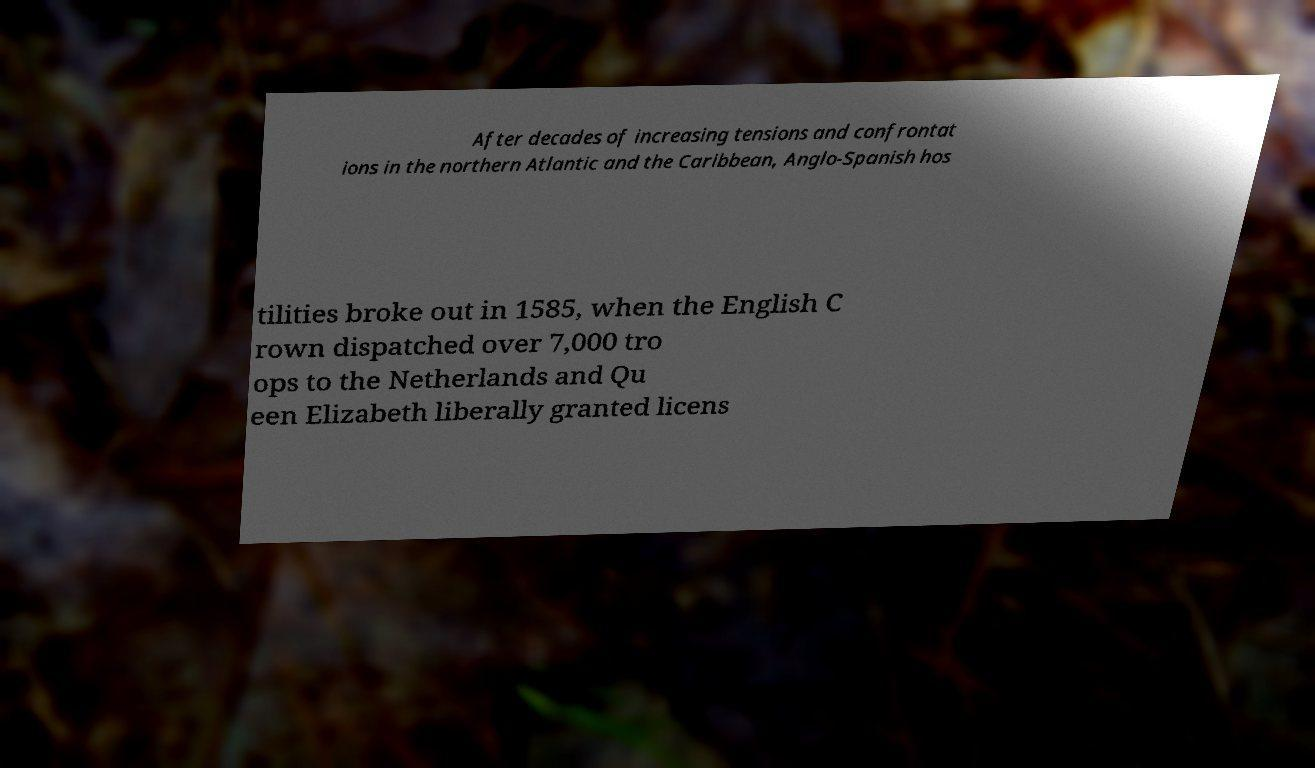What messages or text are displayed in this image? I need them in a readable, typed format. After decades of increasing tensions and confrontat ions in the northern Atlantic and the Caribbean, Anglo-Spanish hos tilities broke out in 1585, when the English C rown dispatched over 7,000 tro ops to the Netherlands and Qu een Elizabeth liberally granted licens 